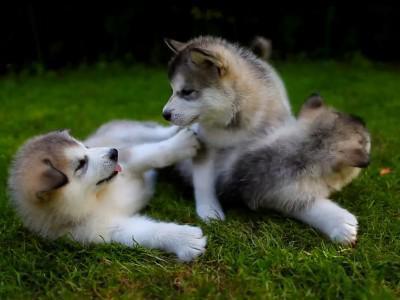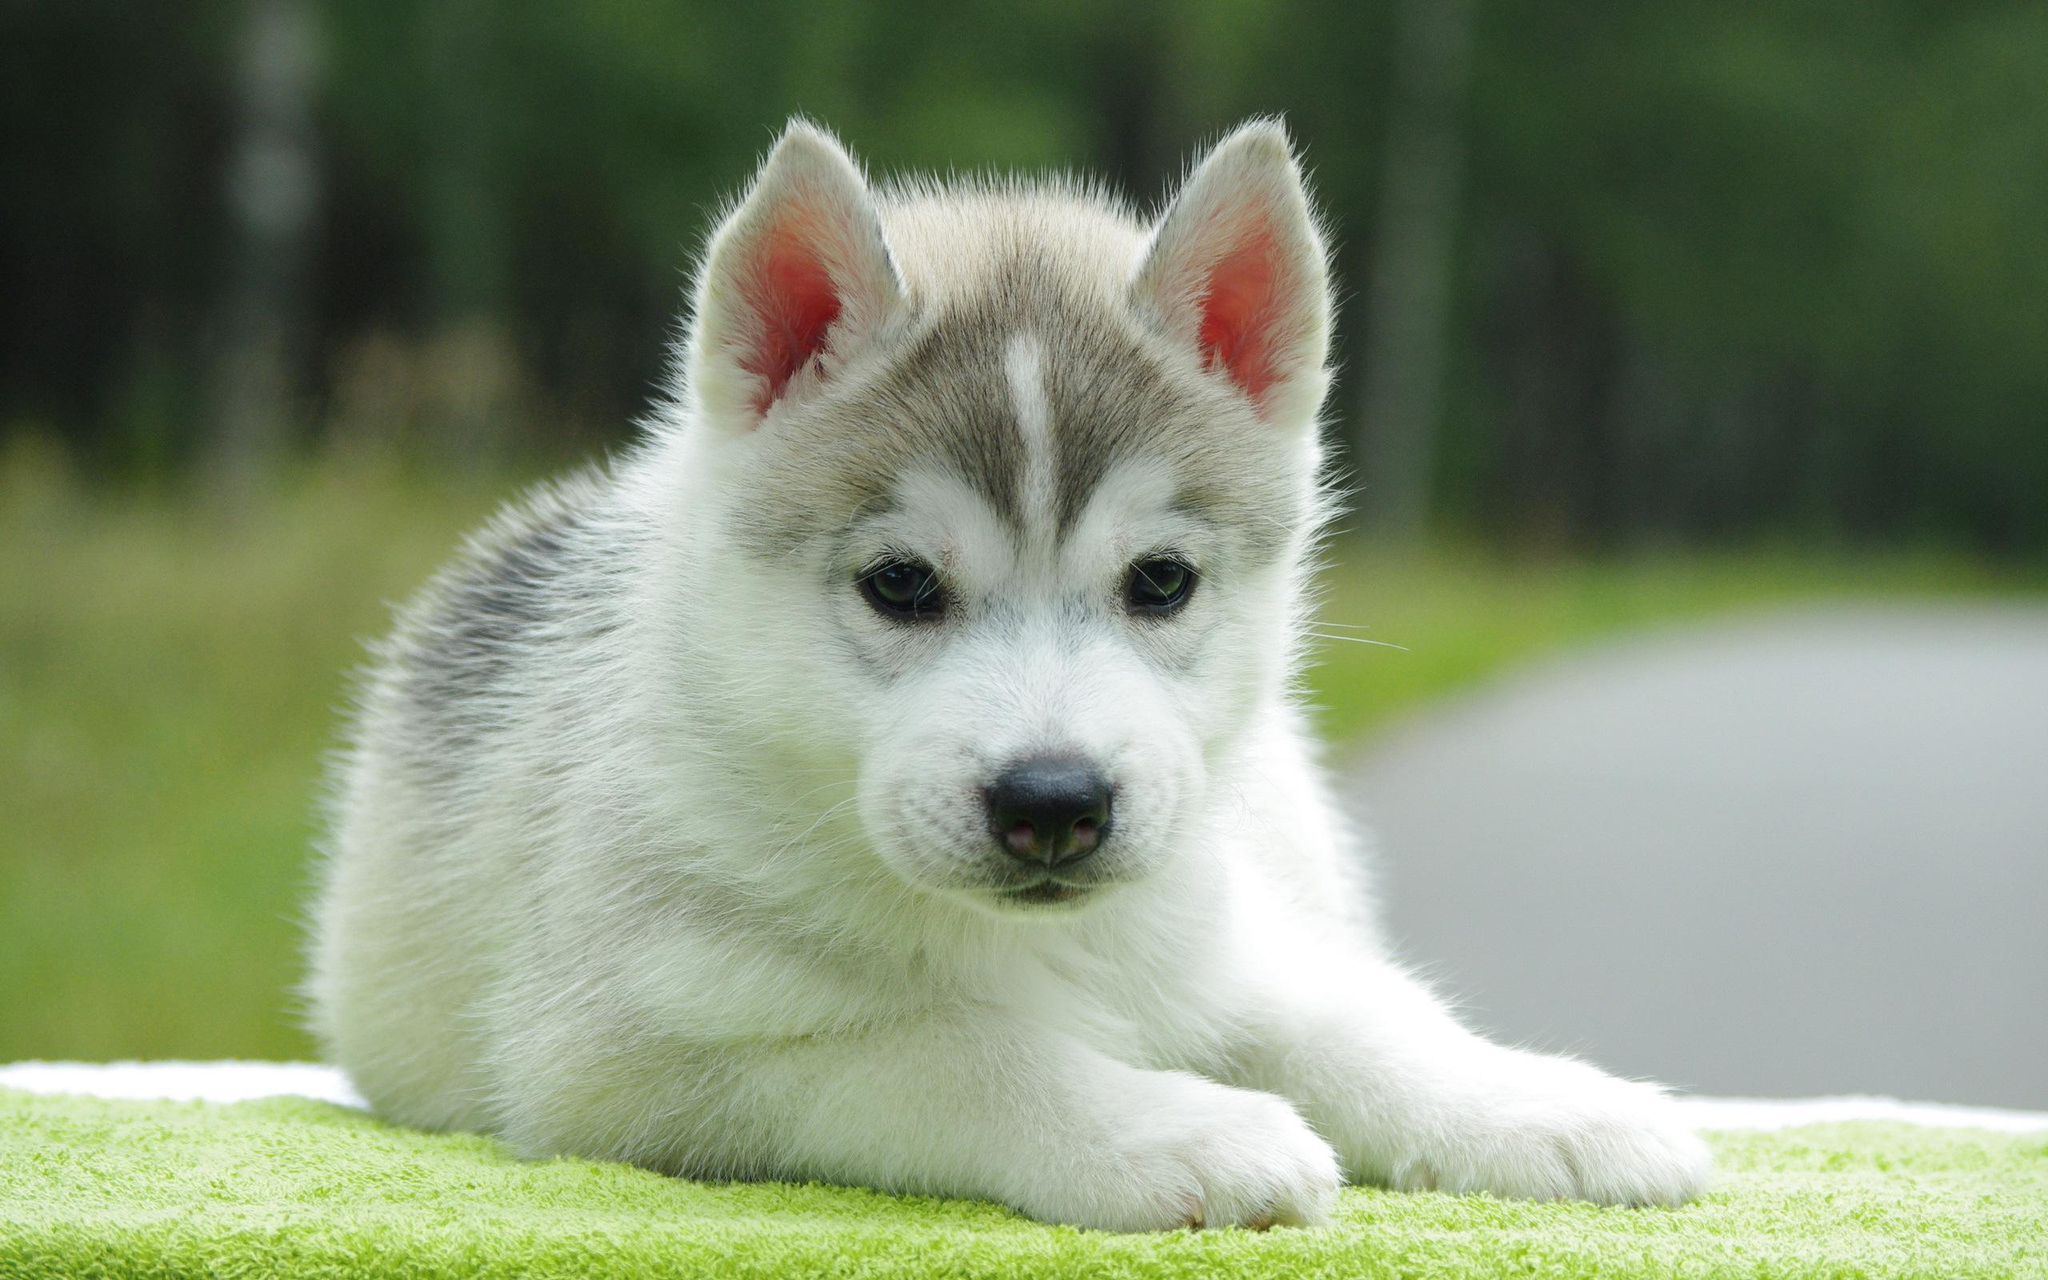The first image is the image on the left, the second image is the image on the right. Assess this claim about the two images: "There is a total of three dogs in both images.". Correct or not? Answer yes or no. No. The first image is the image on the left, the second image is the image on the right. Given the left and right images, does the statement "There are three Husky dogs." hold true? Answer yes or no. No. 